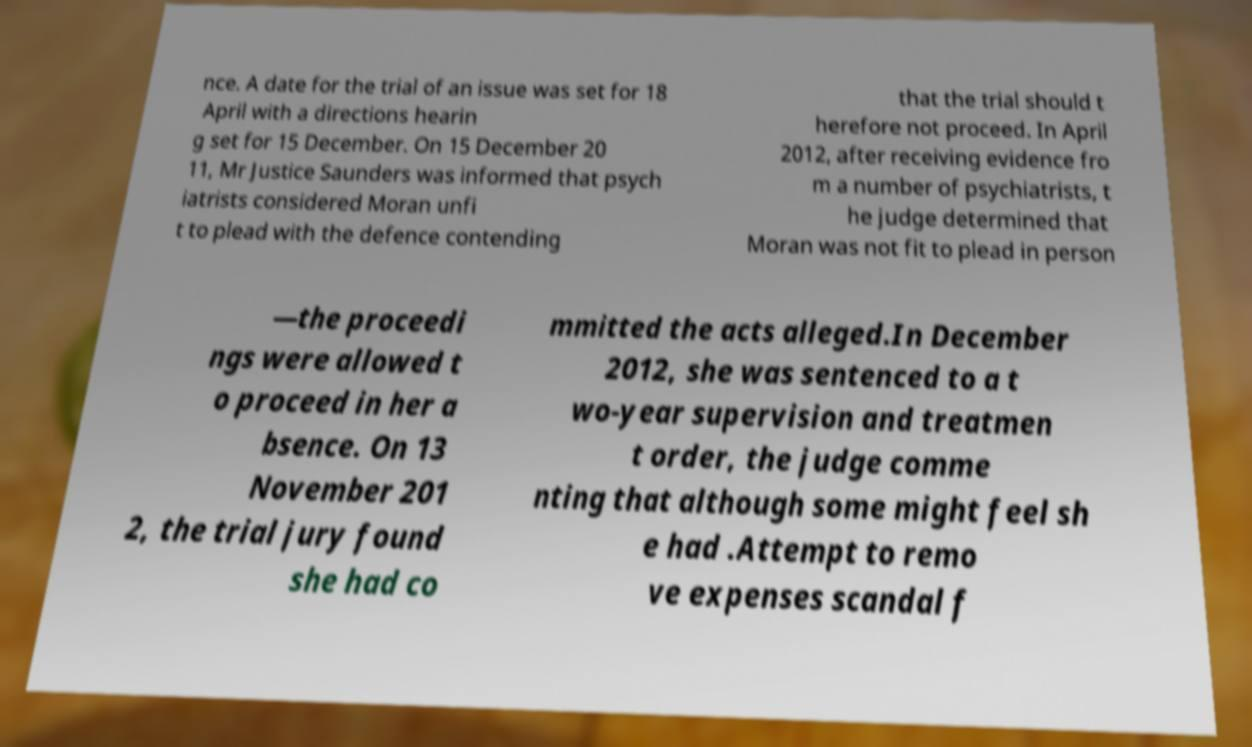Can you accurately transcribe the text from the provided image for me? nce. A date for the trial of an issue was set for 18 April with a directions hearin g set for 15 December. On 15 December 20 11, Mr Justice Saunders was informed that psych iatrists considered Moran unfi t to plead with the defence contending that the trial should t herefore not proceed. In April 2012, after receiving evidence fro m a number of psychiatrists, t he judge determined that Moran was not fit to plead in person —the proceedi ngs were allowed t o proceed in her a bsence. On 13 November 201 2, the trial jury found she had co mmitted the acts alleged.In December 2012, she was sentenced to a t wo-year supervision and treatmen t order, the judge comme nting that although some might feel sh e had .Attempt to remo ve expenses scandal f 